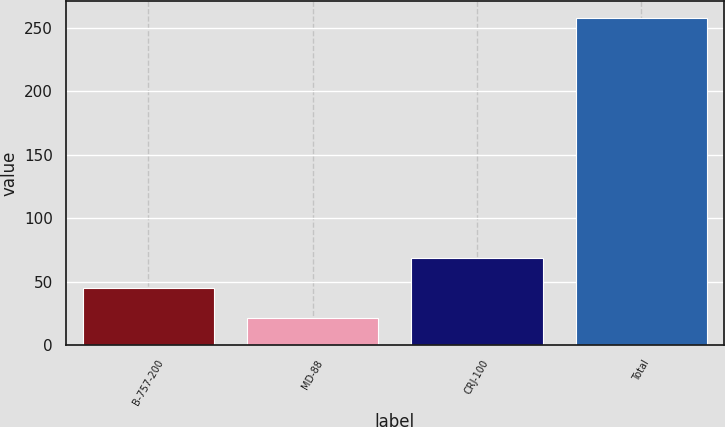<chart> <loc_0><loc_0><loc_500><loc_500><bar_chart><fcel>B-757-200<fcel>MD-88<fcel>CRJ-100<fcel>Total<nl><fcel>44.7<fcel>21<fcel>68.4<fcel>258<nl></chart> 